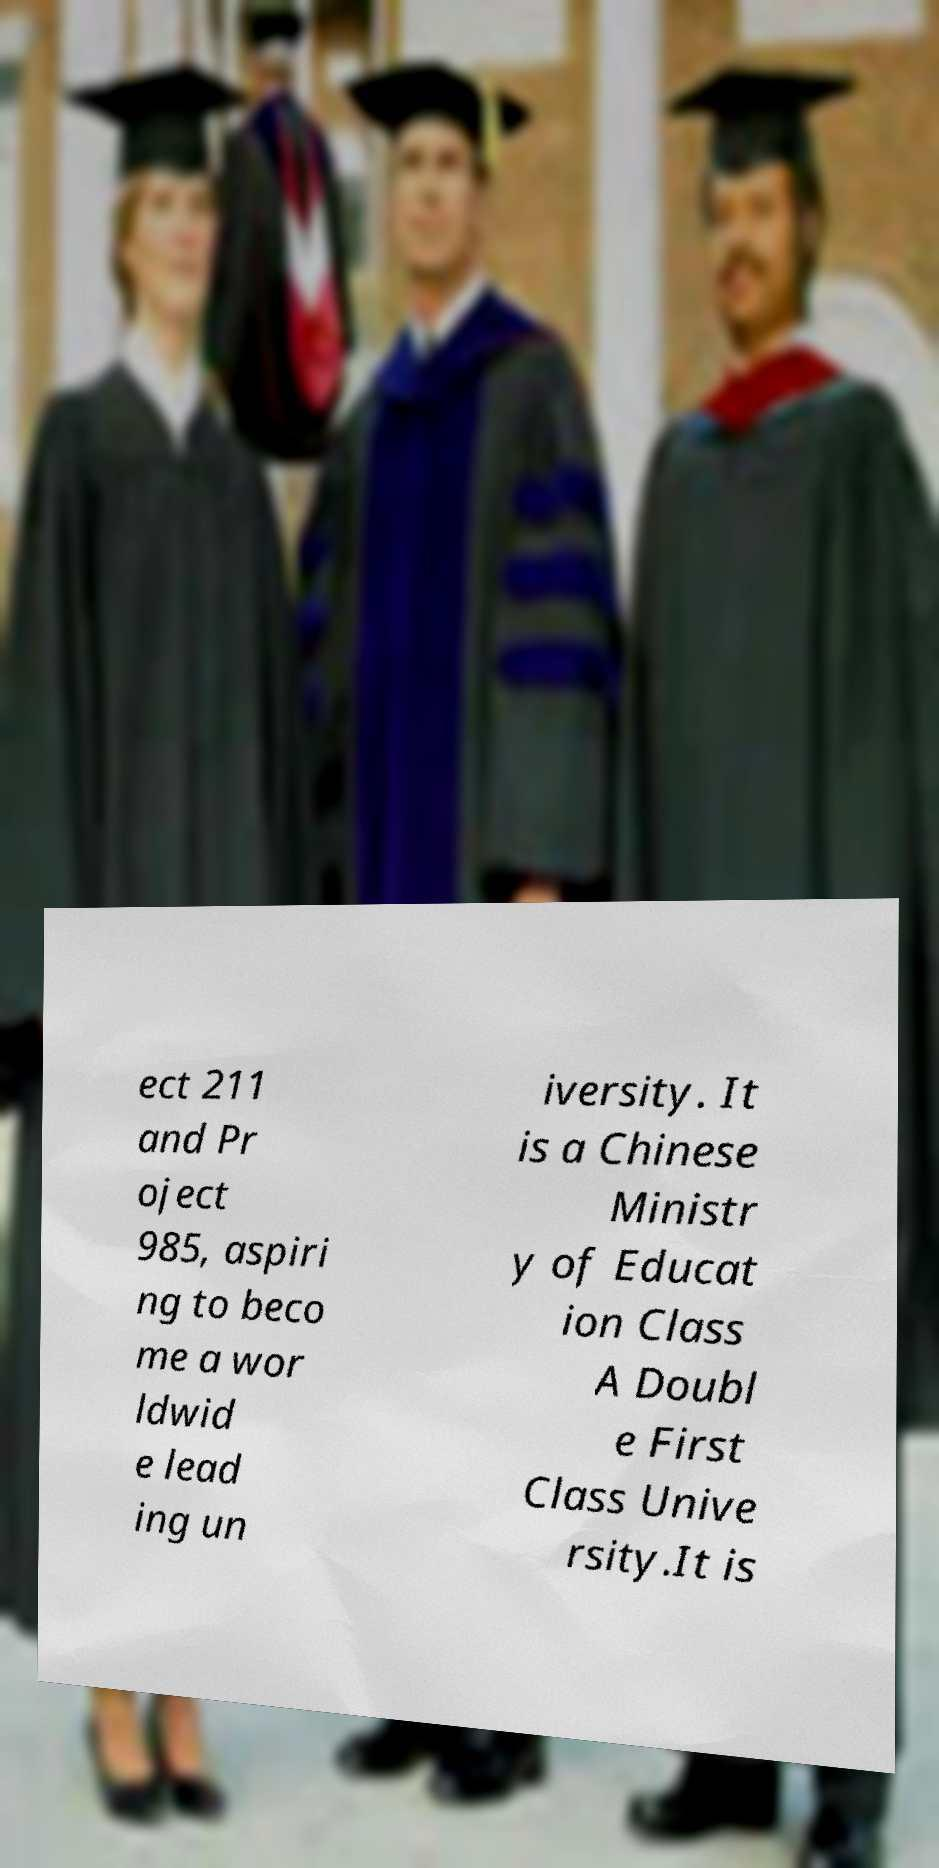Could you assist in decoding the text presented in this image and type it out clearly? ect 211 and Pr oject 985, aspiri ng to beco me a wor ldwid e lead ing un iversity. It is a Chinese Ministr y of Educat ion Class A Doubl e First Class Unive rsity.It is 